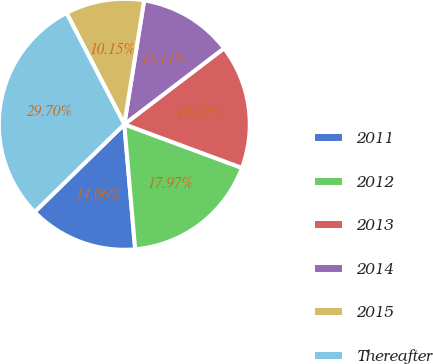Convert chart. <chart><loc_0><loc_0><loc_500><loc_500><pie_chart><fcel>2011<fcel>2012<fcel>2013<fcel>2014<fcel>2015<fcel>Thereafter<nl><fcel>14.06%<fcel>17.97%<fcel>16.02%<fcel>12.11%<fcel>10.15%<fcel>29.7%<nl></chart> 